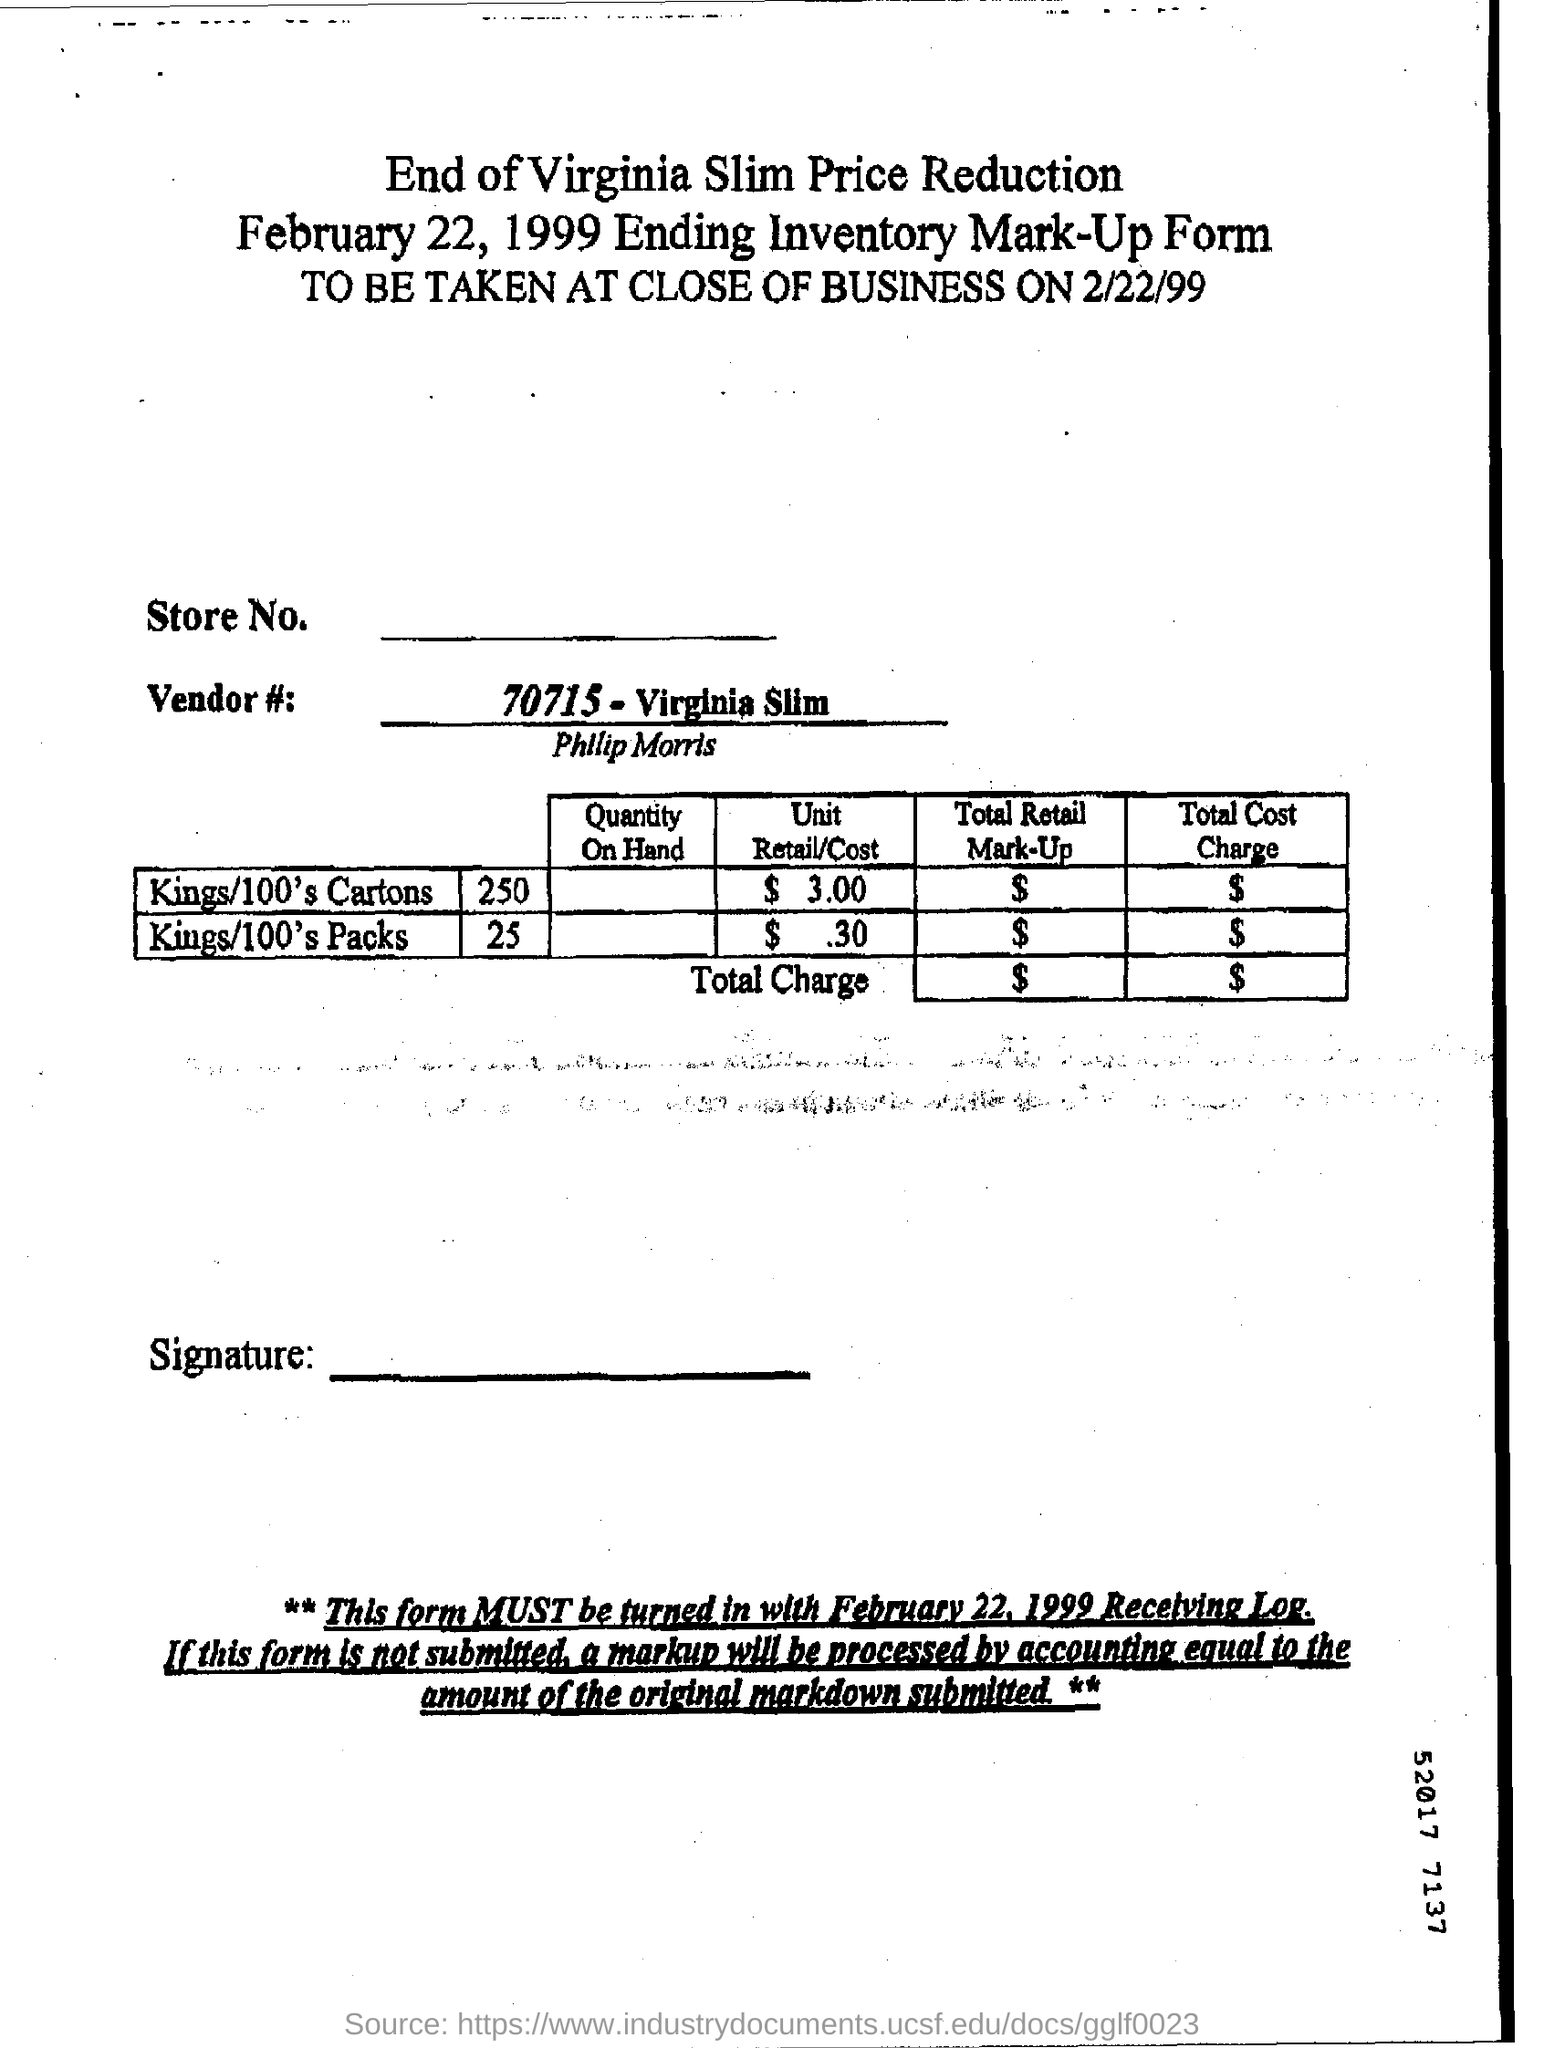Which cigarette brand is mentioned in the title?
Offer a terse response. Virginia Slim. What is the vendor number?
Your response must be concise. 70715 - Virginia Slim. 